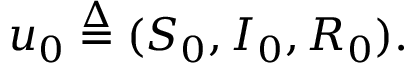<formula> <loc_0><loc_0><loc_500><loc_500>u _ { 0 } \overset { \Delta } { = } ( S _ { 0 } , I _ { 0 } , R _ { 0 } ) .</formula> 